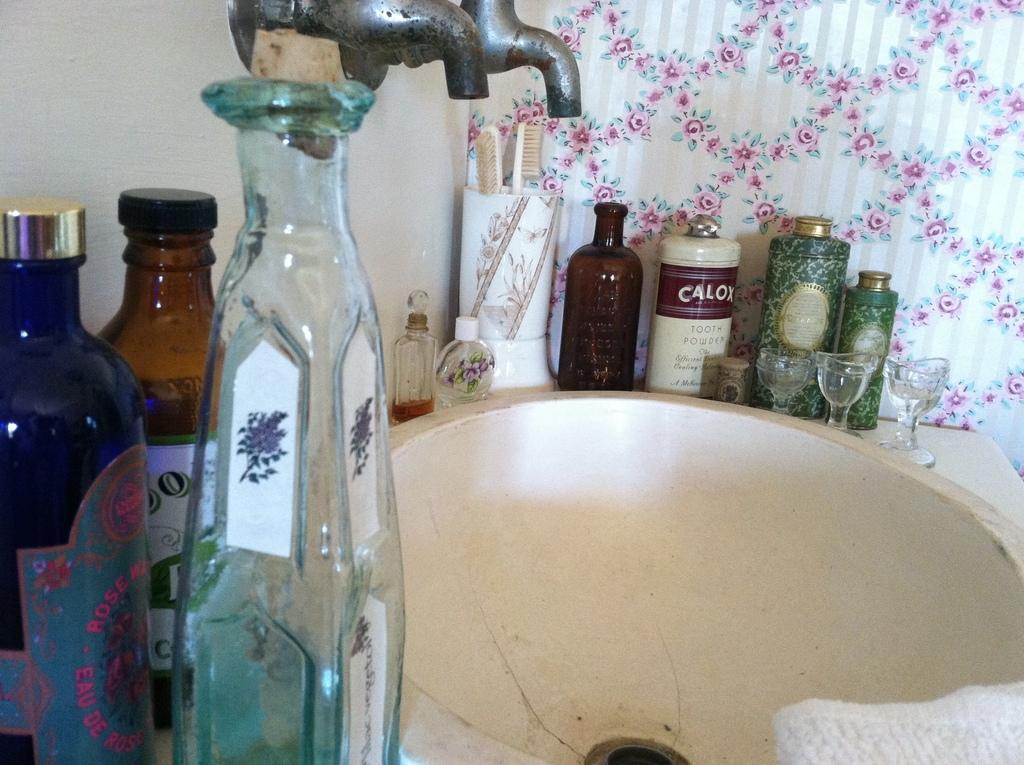Can you describe this image briefly? there are glass bottles in the front left. there are 2 taps and a basin at the center. behind that there are toothbrush, glasses and bottles. and at the back there are curtains. 